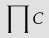<formula> <loc_0><loc_0><loc_500><loc_500>\prod C</formula> 